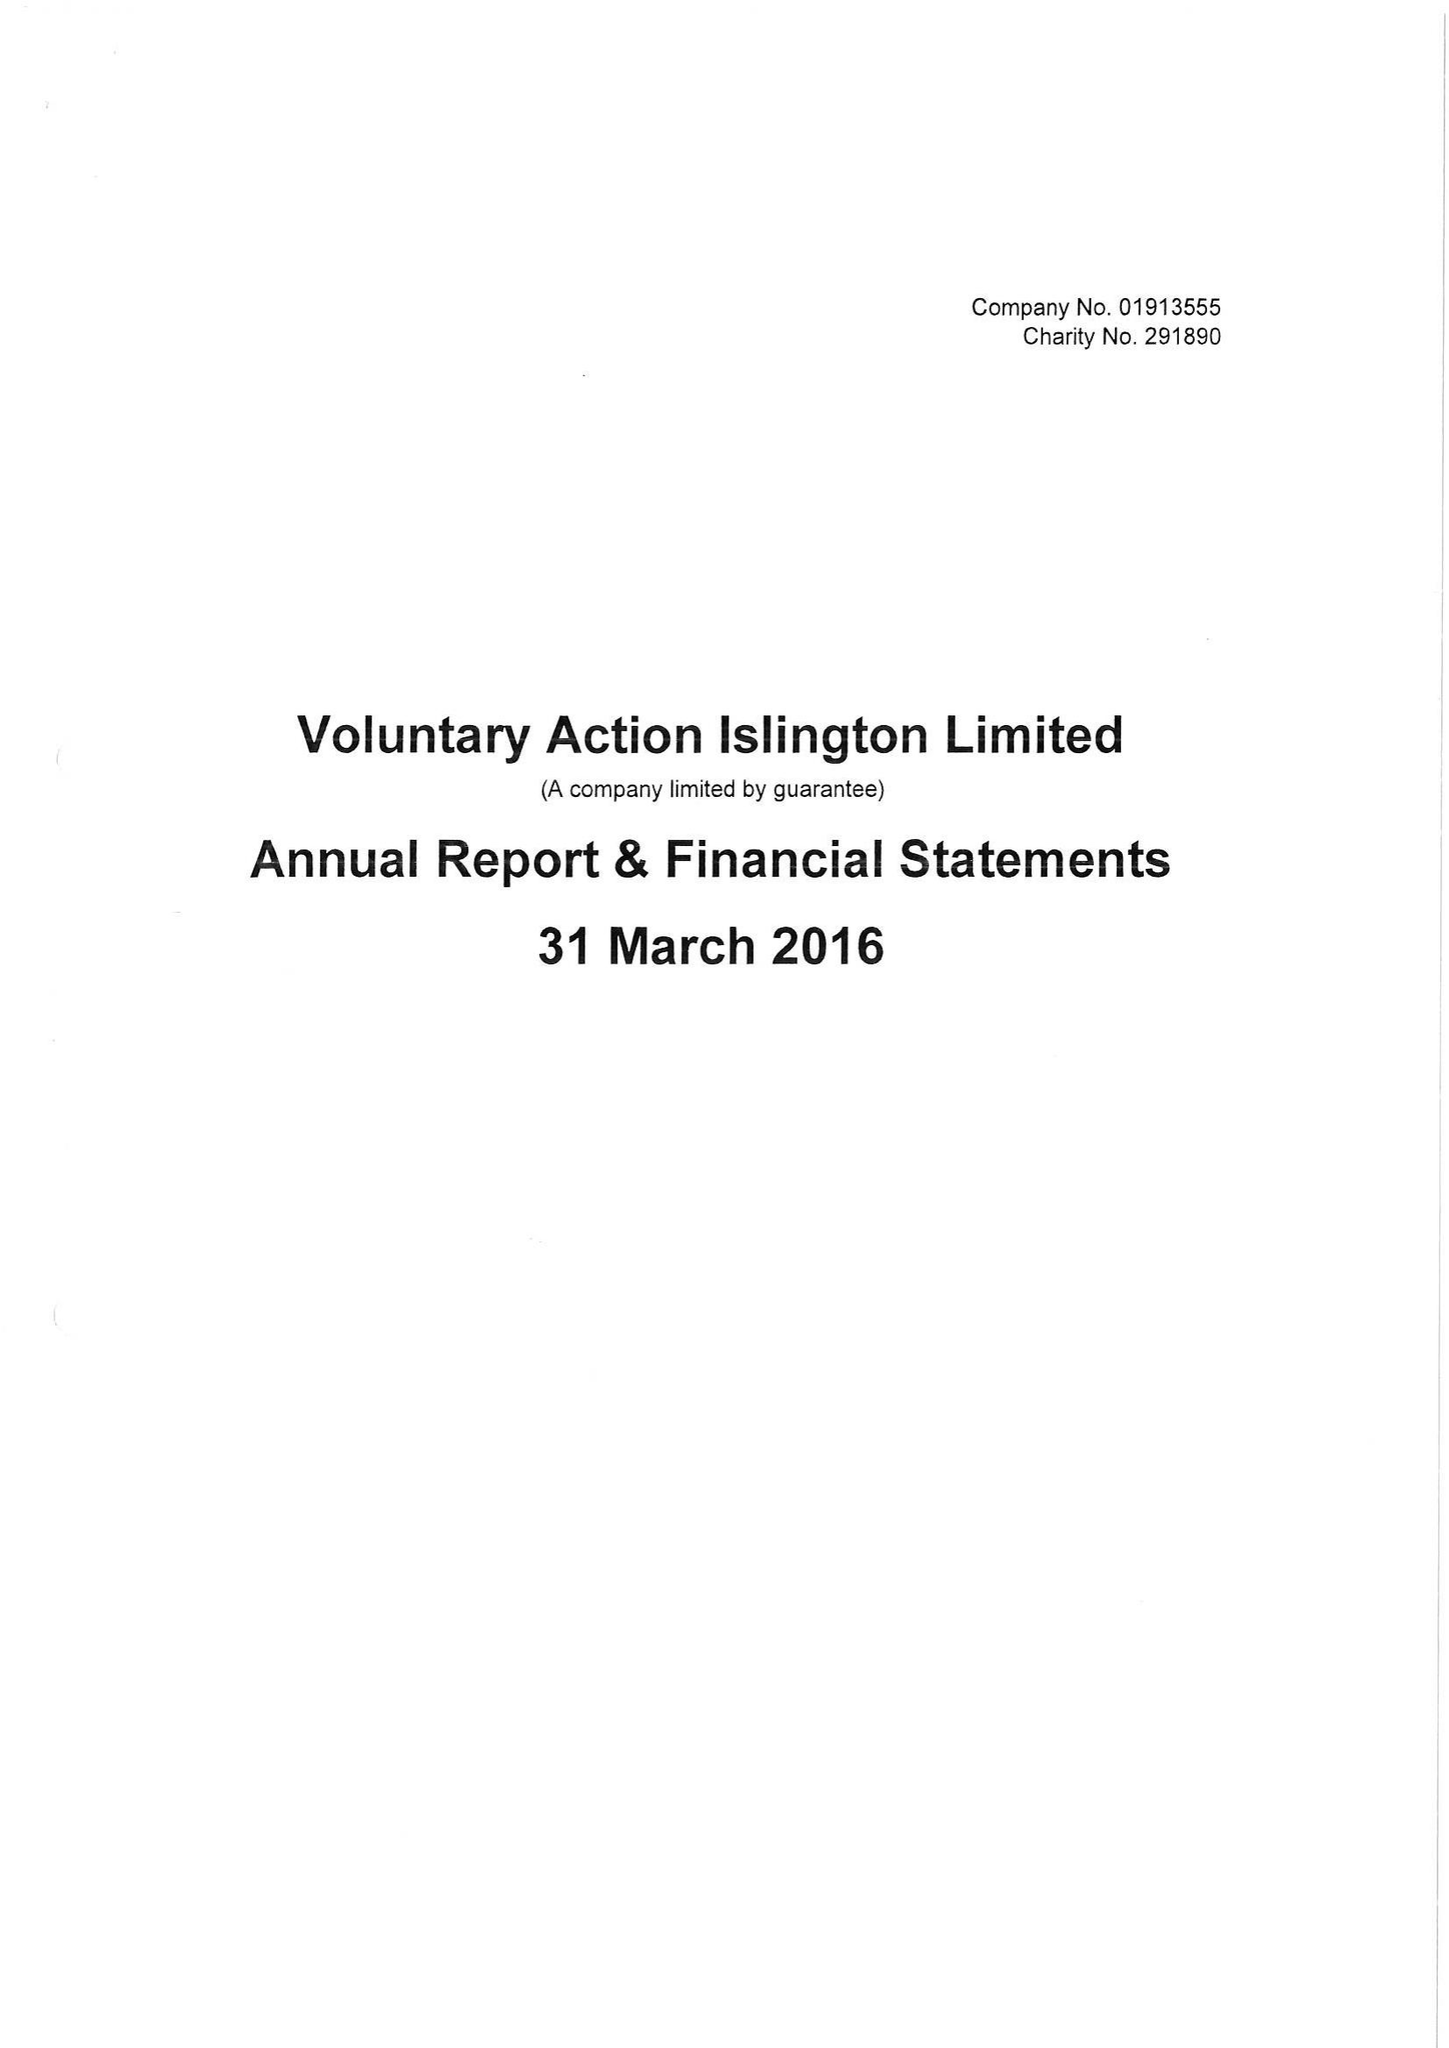What is the value for the address__street_line?
Answer the question using a single word or phrase. 200A PENTONVILLE ROAD 